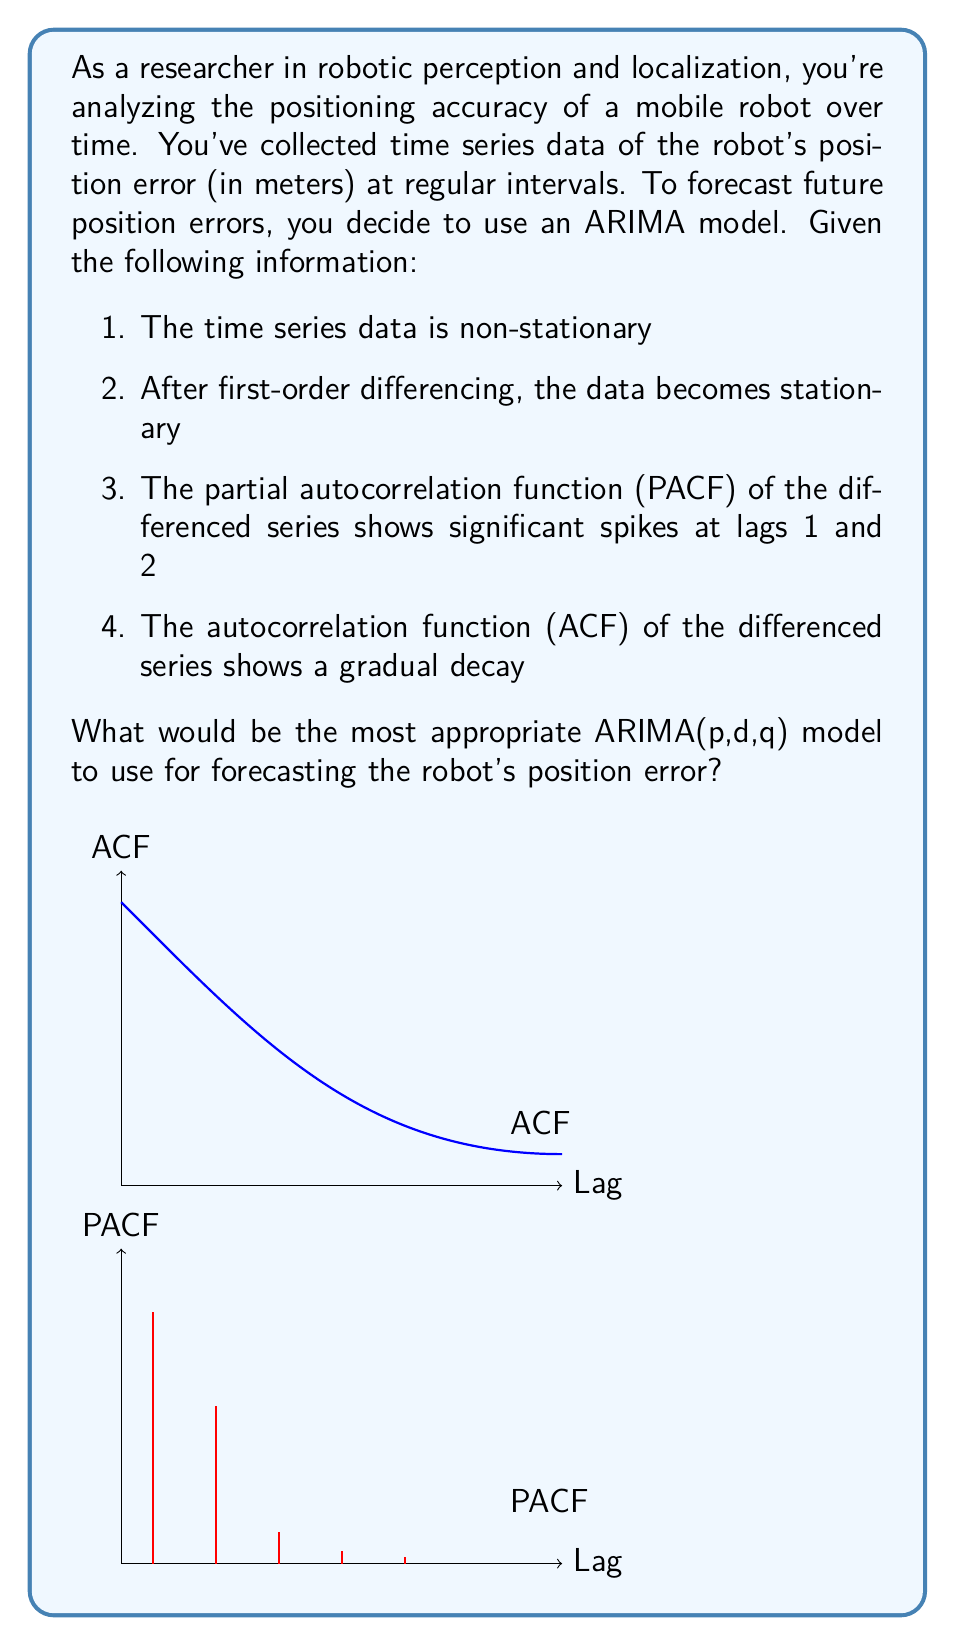Help me with this question. To determine the appropriate ARIMA(p,d,q) model, we need to analyze the given information:

1. The original series is non-stationary, which means we need differencing. This determines the 'd' parameter.
2. First-order differencing makes the series stationary, so d = 1.

3. For the 'p' parameter (AR order):
   - We look at the PACF of the differenced series.
   - Significant spikes at lags 1 and 2 suggest p = 2.

4. For the 'q' parameter (MA order):
   - We examine the ACF of the differenced series.
   - A gradual decay in the ACF suggests a moving average component.
   - Let's choose q = 1 as a starting point.

Therefore, based on this analysis, the most appropriate model would be ARIMA(2,1,1).

This model can be expressed mathematically as:

$$(1 - \phi_1B - \phi_2B^2)(1 - B)y_t = (1 + \theta_1B)\epsilon_t$$

Where:
- $y_t$ is the time series
- $B$ is the backshift operator
- $\phi_1$ and $\phi_2$ are the AR parameters
- $\theta_1$ is the MA parameter
- $\epsilon_t$ is the error term

This ARIMA(2,1,1) model combines:
- Second-order autoregression (AR(2))
- First-order differencing (I(1))
- First-order moving average (MA(1))

It should capture both the trend and the short-term correlations in the robot's position error data, making it suitable for forecasting future errors.
Answer: ARIMA(2,1,1) 